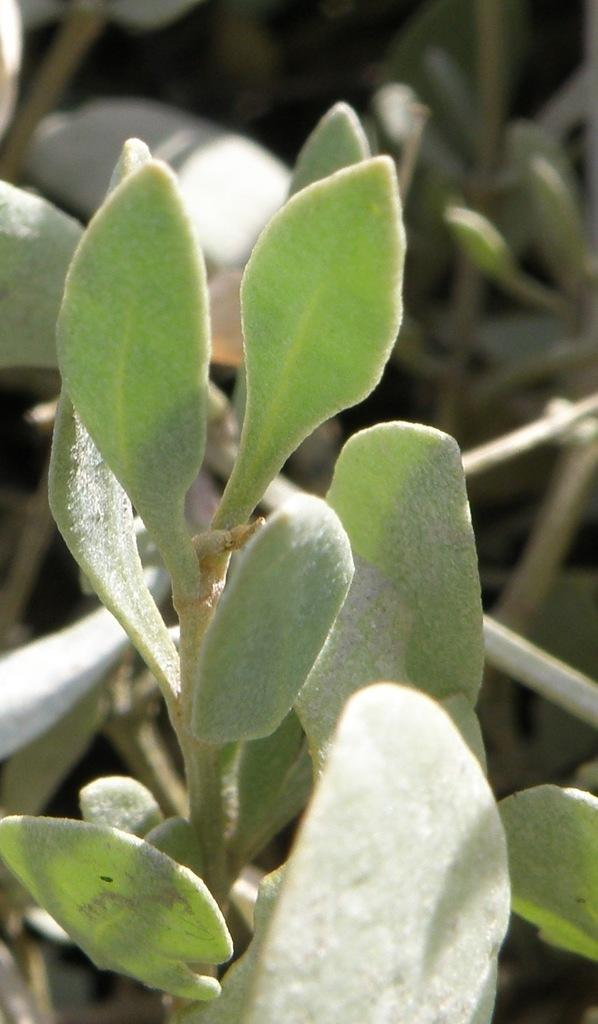What is the main subject of the image? The main subject of the image is plants. Where are the plants located in the image? The plants are in the center of the image. How many rings does the farmer wear while saying good-bye to the plants in the image? There is no farmer or rings present in the image, and the plants are not depicted as being involved in any good-bye scenario. 